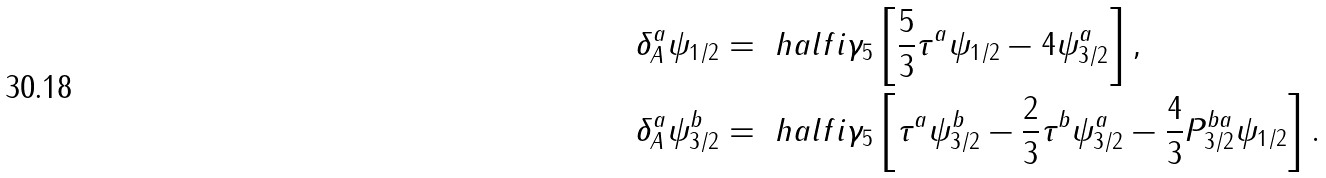<formula> <loc_0><loc_0><loc_500><loc_500>\delta _ { A } ^ { a } \psi _ { 1 / 2 } & = \ h a l f i \gamma _ { 5 } \left [ \frac { 5 } { 3 } \tau ^ { a } \psi _ { 1 / 2 } - 4 \psi _ { 3 / 2 } ^ { a } \right ] , \\ \delta _ { A } ^ { a } \psi _ { 3 / 2 } ^ { b } & = \ h a l f i \gamma _ { 5 } \left [ \tau ^ { a } \psi _ { 3 / 2 } ^ { b } - \frac { 2 } { 3 } \tau ^ { b } \psi _ { 3 / 2 } ^ { a } - \frac { 4 } { 3 } P ^ { b a } _ { 3 / 2 } \psi _ { 1 / 2 } \right ] .</formula> 